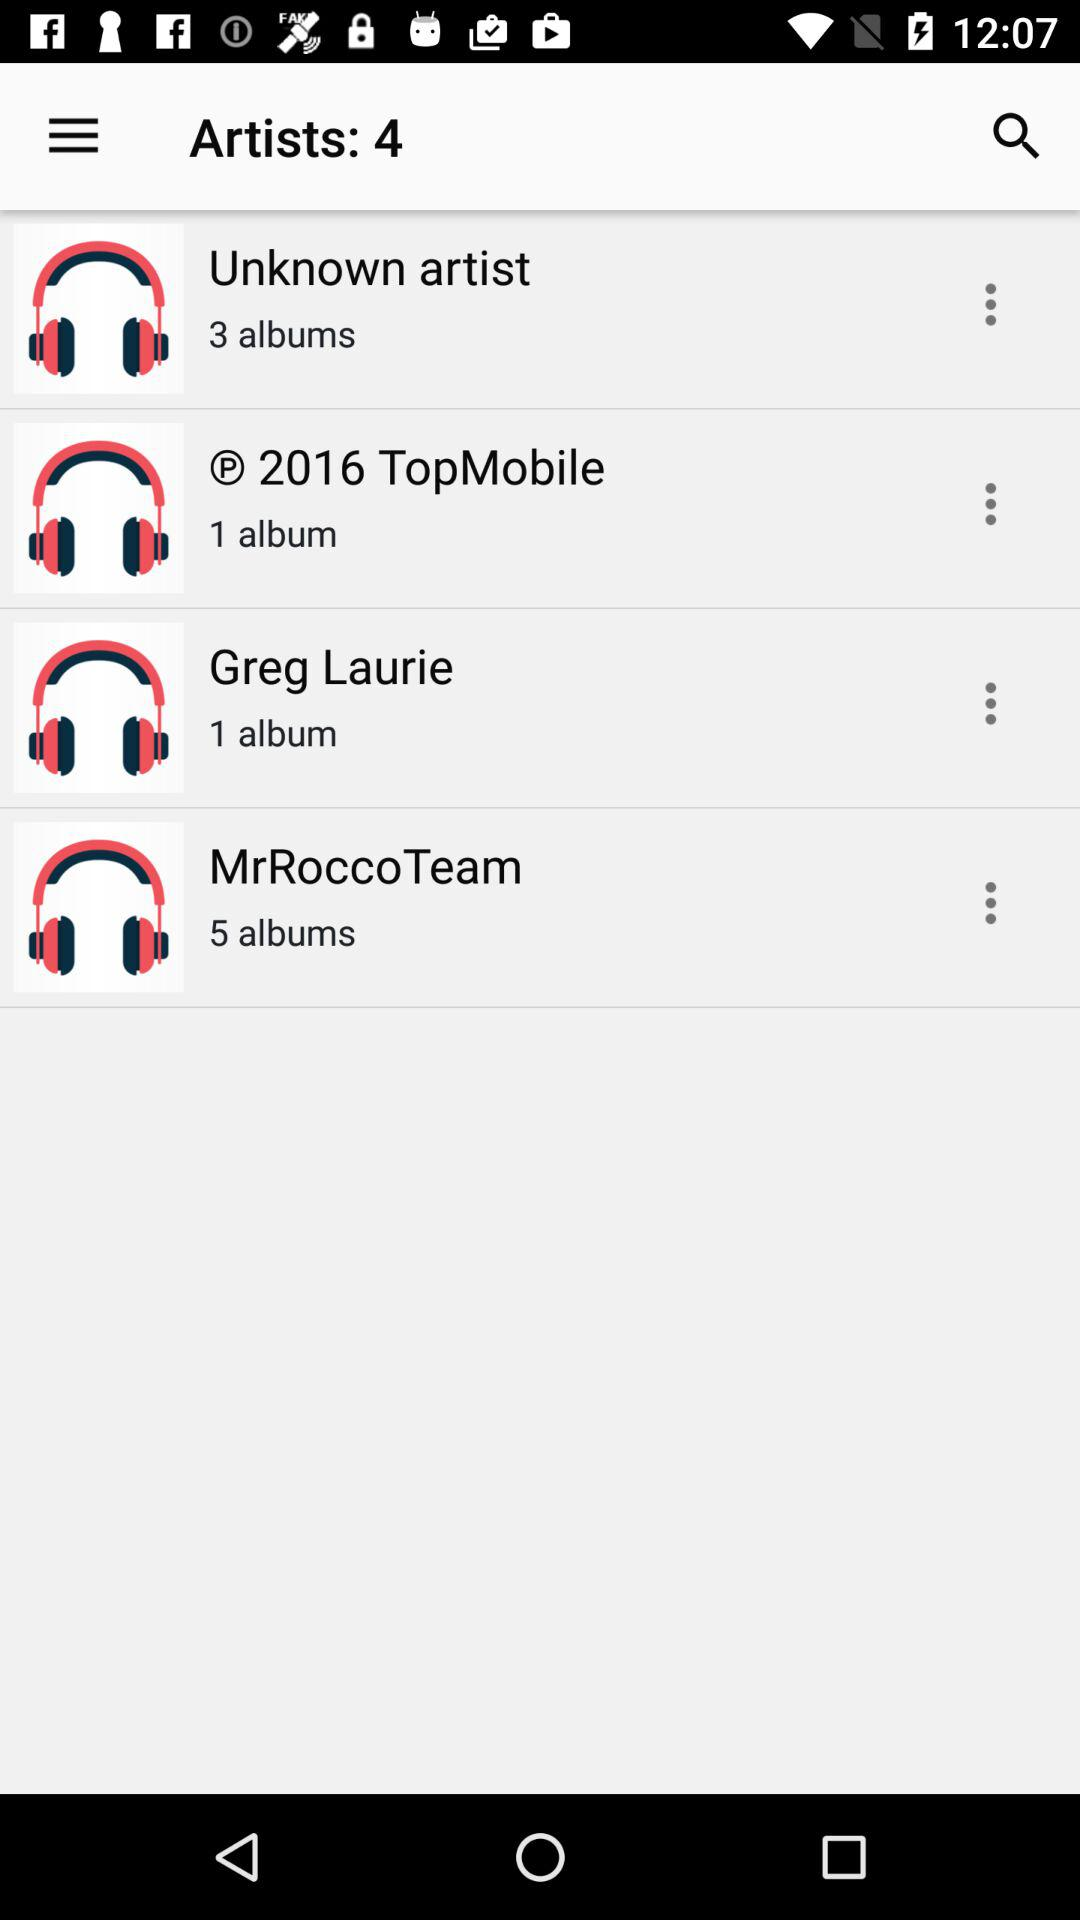How many albums does MrRocco Team have?
Answer the question using a single word or phrase. 5 